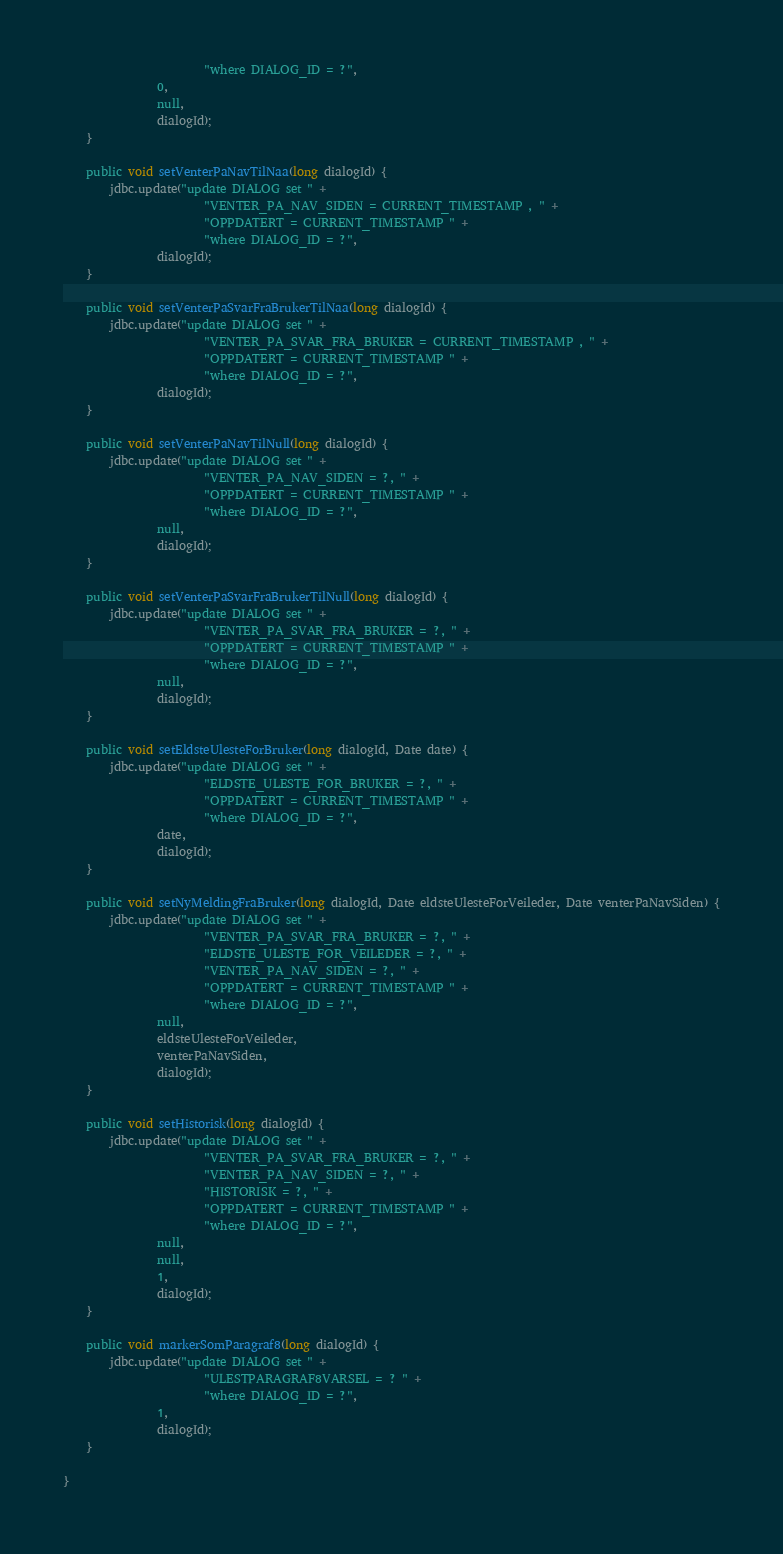<code> <loc_0><loc_0><loc_500><loc_500><_Java_>                        "where DIALOG_ID = ?",
                0,
                null,
                dialogId);
    }

    public void setVenterPaNavTilNaa(long dialogId) {
        jdbc.update("update DIALOG set " +
                        "VENTER_PA_NAV_SIDEN = CURRENT_TIMESTAMP , " +
                        "OPPDATERT = CURRENT_TIMESTAMP " +
                        "where DIALOG_ID = ?",
                dialogId);
    }

    public void setVenterPaSvarFraBrukerTilNaa(long dialogId) {
        jdbc.update("update DIALOG set " +
                        "VENTER_PA_SVAR_FRA_BRUKER = CURRENT_TIMESTAMP , " +
                        "OPPDATERT = CURRENT_TIMESTAMP " +
                        "where DIALOG_ID = ?",
                dialogId);
    }

    public void setVenterPaNavTilNull(long dialogId) {
        jdbc.update("update DIALOG set " +
                        "VENTER_PA_NAV_SIDEN = ?, " +
                        "OPPDATERT = CURRENT_TIMESTAMP " +
                        "where DIALOG_ID = ?",
                null,
                dialogId);
    }

    public void setVenterPaSvarFraBrukerTilNull(long dialogId) {
        jdbc.update("update DIALOG set " +
                        "VENTER_PA_SVAR_FRA_BRUKER = ?, " +
                        "OPPDATERT = CURRENT_TIMESTAMP " +
                        "where DIALOG_ID = ?",
                null,
                dialogId);
    }

    public void setEldsteUlesteForBruker(long dialogId, Date date) {
        jdbc.update("update DIALOG set " +
                        "ELDSTE_ULESTE_FOR_BRUKER = ?, " +
                        "OPPDATERT = CURRENT_TIMESTAMP " +
                        "where DIALOG_ID = ?",
                date,
                dialogId);
    }

    public void setNyMeldingFraBruker(long dialogId, Date eldsteUlesteForVeileder, Date venterPaNavSiden) {
        jdbc.update("update DIALOG set " +
                        "VENTER_PA_SVAR_FRA_BRUKER = ?, " +
                        "ELDSTE_ULESTE_FOR_VEILEDER = ?, " +
                        "VENTER_PA_NAV_SIDEN = ?, " +
                        "OPPDATERT = CURRENT_TIMESTAMP " +
                        "where DIALOG_ID = ?",
                null,
                eldsteUlesteForVeileder,
                venterPaNavSiden,
                dialogId);
    }

    public void setHistorisk(long dialogId) {
        jdbc.update("update DIALOG set " +
                        "VENTER_PA_SVAR_FRA_BRUKER = ?, " +
                        "VENTER_PA_NAV_SIDEN = ?, " +
                        "HISTORISK = ?, " +
                        "OPPDATERT = CURRENT_TIMESTAMP " +
                        "where DIALOG_ID = ?",
                null,
                null,
                1,
                dialogId);
    }

    public void markerSomParagraf8(long dialogId) {
        jdbc.update("update DIALOG set " +
                        "ULESTPARAGRAF8VARSEL = ? " +
                        "where DIALOG_ID = ?",
                1,
                dialogId);
    }

}
</code> 